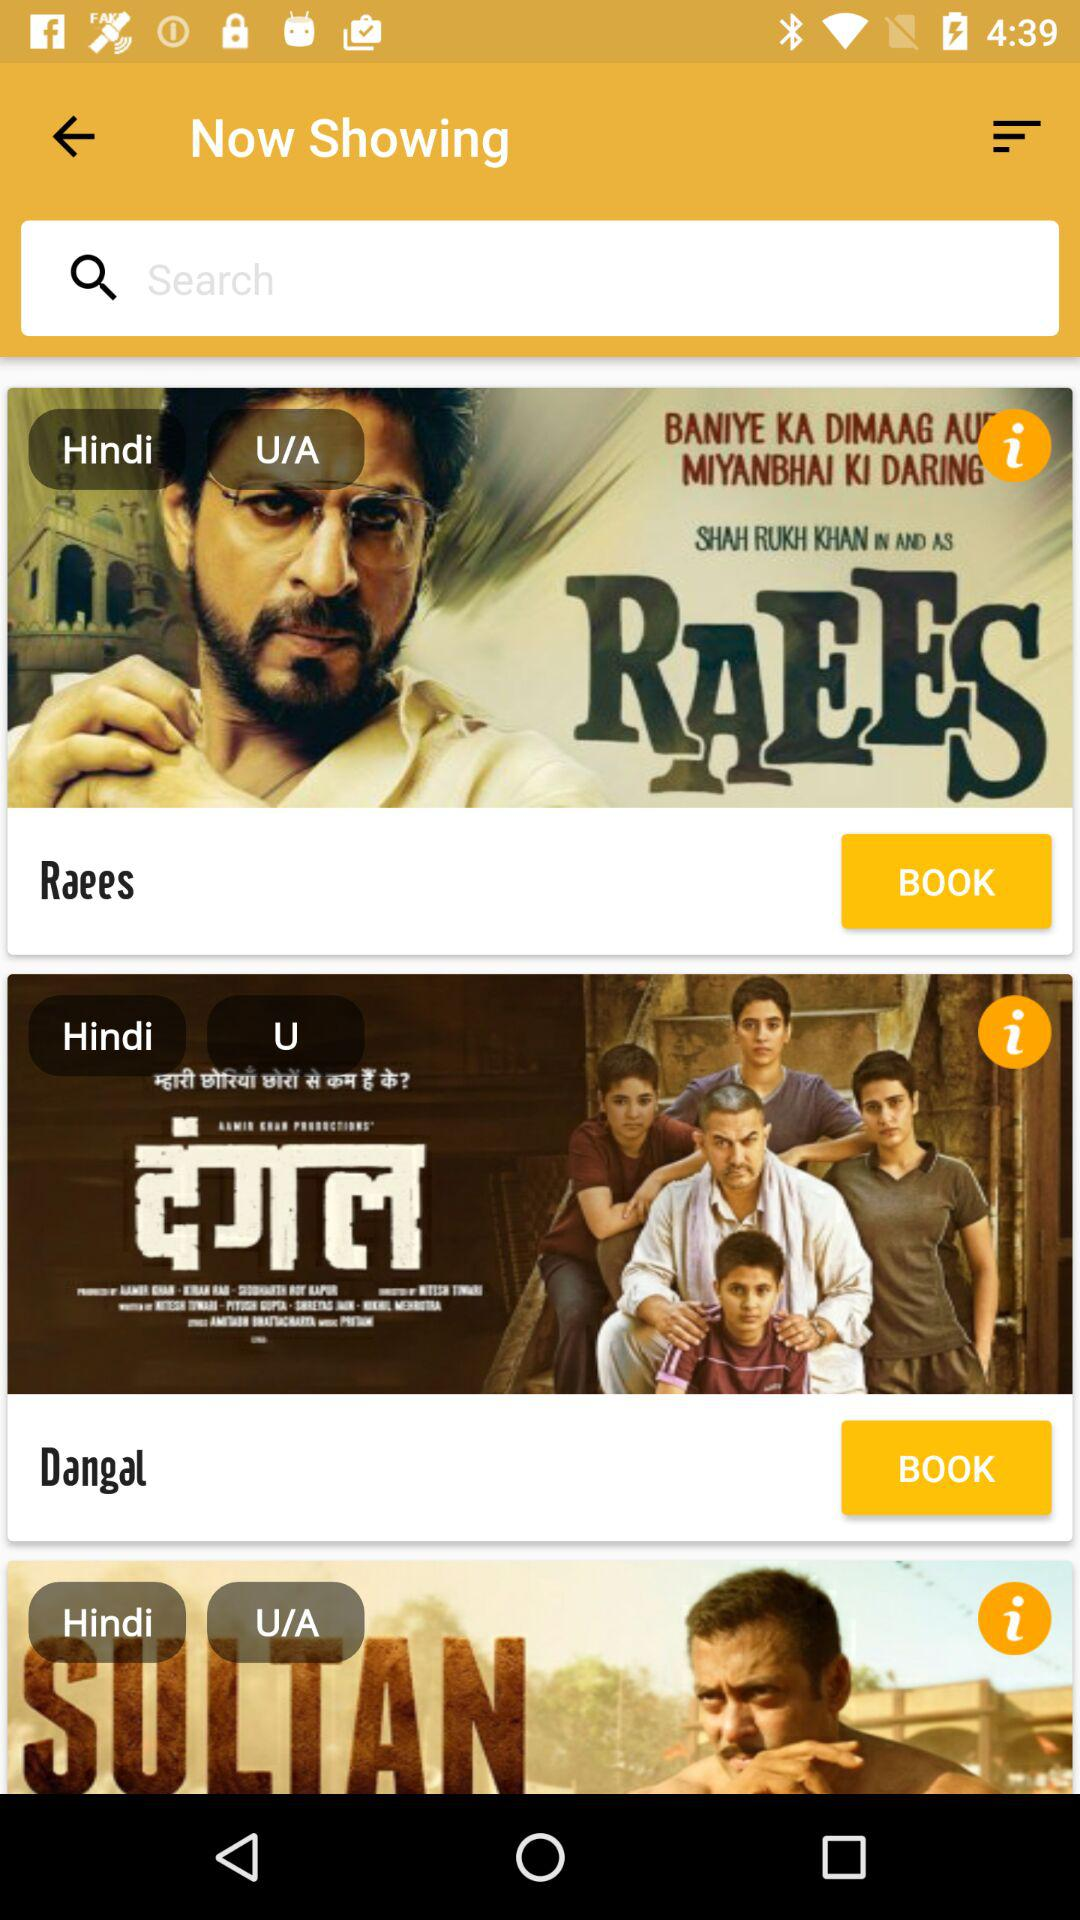What are the names of the different Hindi movies shown on the screen? The names of the different Hindi movies shown on the screen are "Raees" and "Dangal". 